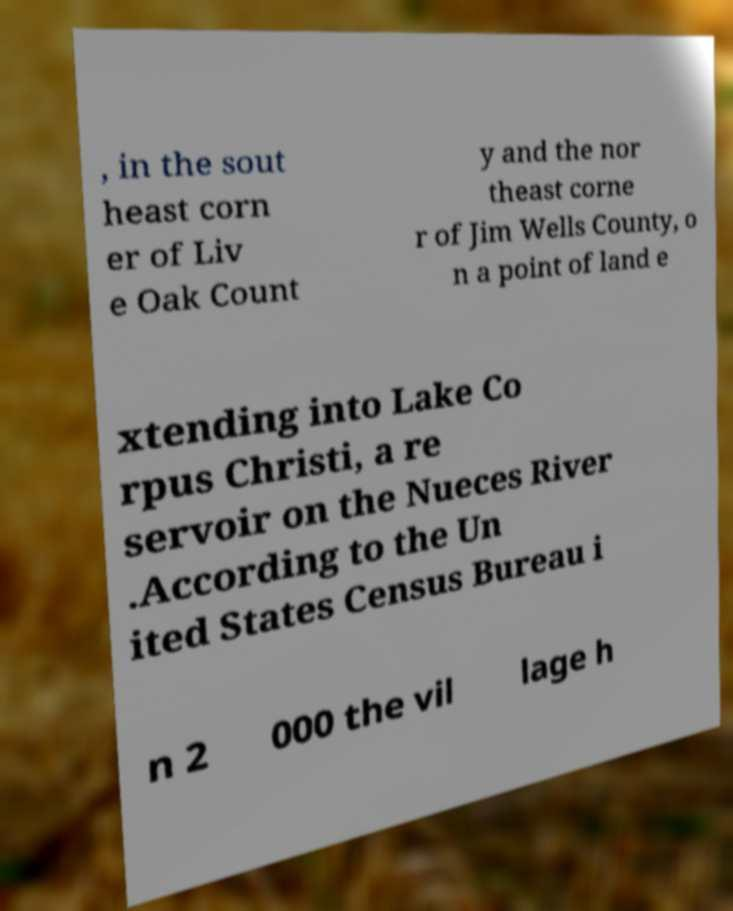For documentation purposes, I need the text within this image transcribed. Could you provide that? , in the sout heast corn er of Liv e Oak Count y and the nor theast corne r of Jim Wells County, o n a point of land e xtending into Lake Co rpus Christi, a re servoir on the Nueces River .According to the Un ited States Census Bureau i n 2 000 the vil lage h 